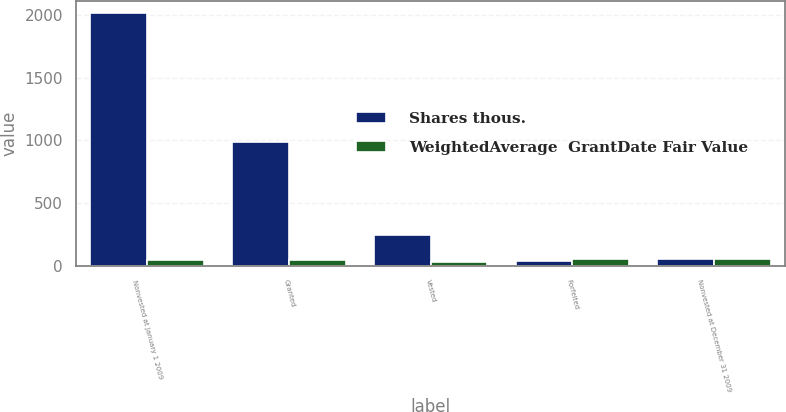Convert chart. <chart><loc_0><loc_0><loc_500><loc_500><stacked_bar_chart><ecel><fcel>Nonvested at January 1 2009<fcel>Granted<fcel>Vested<fcel>Forfeited<fcel>Nonvested at December 31 2009<nl><fcel>Shares thous.<fcel>2015<fcel>988<fcel>243<fcel>41<fcel>50.13<nl><fcel>WeightedAverage  GrantDate Fair Value<fcel>49.39<fcel>47.43<fcel>32.84<fcel>51.58<fcel>50.13<nl></chart> 